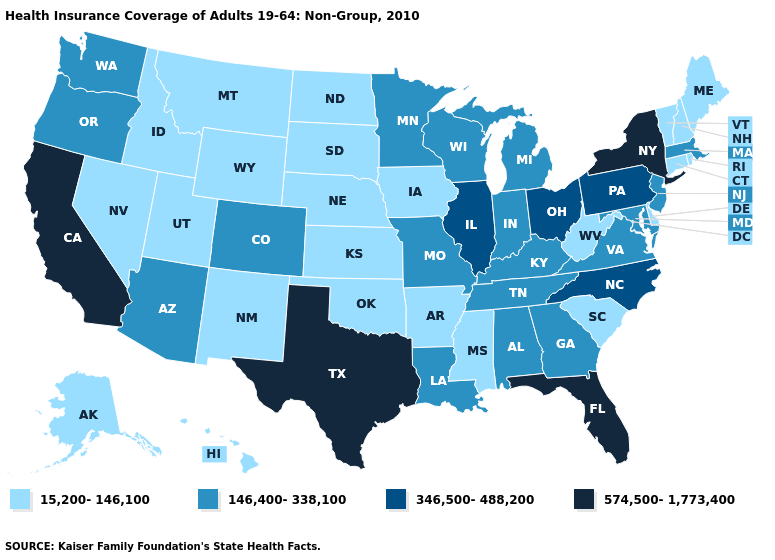Name the states that have a value in the range 346,500-488,200?
Answer briefly. Illinois, North Carolina, Ohio, Pennsylvania. What is the value of Missouri?
Be succinct. 146,400-338,100. What is the value of Iowa?
Short answer required. 15,200-146,100. What is the highest value in the Northeast ?
Answer briefly. 574,500-1,773,400. Does Ohio have the lowest value in the USA?
Write a very short answer. No. Which states have the lowest value in the USA?
Keep it brief. Alaska, Arkansas, Connecticut, Delaware, Hawaii, Idaho, Iowa, Kansas, Maine, Mississippi, Montana, Nebraska, Nevada, New Hampshire, New Mexico, North Dakota, Oklahoma, Rhode Island, South Carolina, South Dakota, Utah, Vermont, West Virginia, Wyoming. Name the states that have a value in the range 346,500-488,200?
Concise answer only. Illinois, North Carolina, Ohio, Pennsylvania. What is the value of Iowa?
Quick response, please. 15,200-146,100. Does Virginia have the same value as Maine?
Give a very brief answer. No. Does Florida have the highest value in the South?
Give a very brief answer. Yes. What is the value of Maine?
Quick response, please. 15,200-146,100. What is the value of Illinois?
Answer briefly. 346,500-488,200. Which states have the lowest value in the USA?
Quick response, please. Alaska, Arkansas, Connecticut, Delaware, Hawaii, Idaho, Iowa, Kansas, Maine, Mississippi, Montana, Nebraska, Nevada, New Hampshire, New Mexico, North Dakota, Oklahoma, Rhode Island, South Carolina, South Dakota, Utah, Vermont, West Virginia, Wyoming. Among the states that border South Dakota , does Minnesota have the highest value?
Write a very short answer. Yes. Name the states that have a value in the range 15,200-146,100?
Answer briefly. Alaska, Arkansas, Connecticut, Delaware, Hawaii, Idaho, Iowa, Kansas, Maine, Mississippi, Montana, Nebraska, Nevada, New Hampshire, New Mexico, North Dakota, Oklahoma, Rhode Island, South Carolina, South Dakota, Utah, Vermont, West Virginia, Wyoming. 